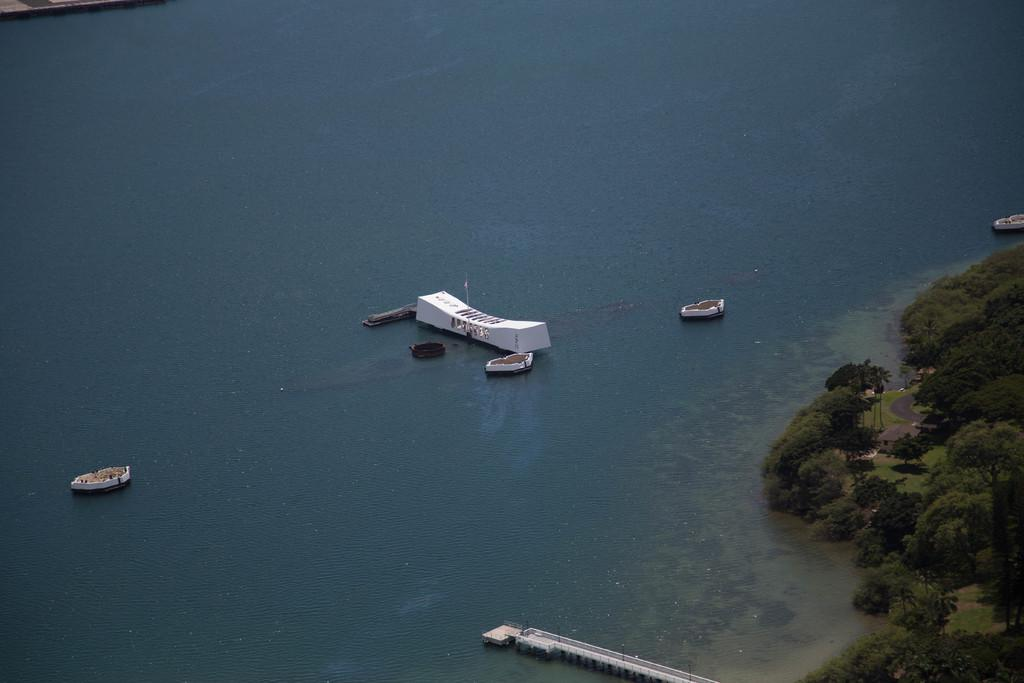What is on the water in the image? There are boats on the water in the image. What type of natural environment is visible in the image? There are trees visible in the image. What structure can be seen in the image? There is a bridge in the image. What additional detail can be seen in the image? There is a flag in the image. How much sugar is in the boats in the image? There is no mention of sugar in the image, as it features boats on the water, trees, a bridge, and a flag. What does the look on the trees in the image signify? There is no indication of a look or expression on the trees in the image, as they are simply part of the natural environment. 